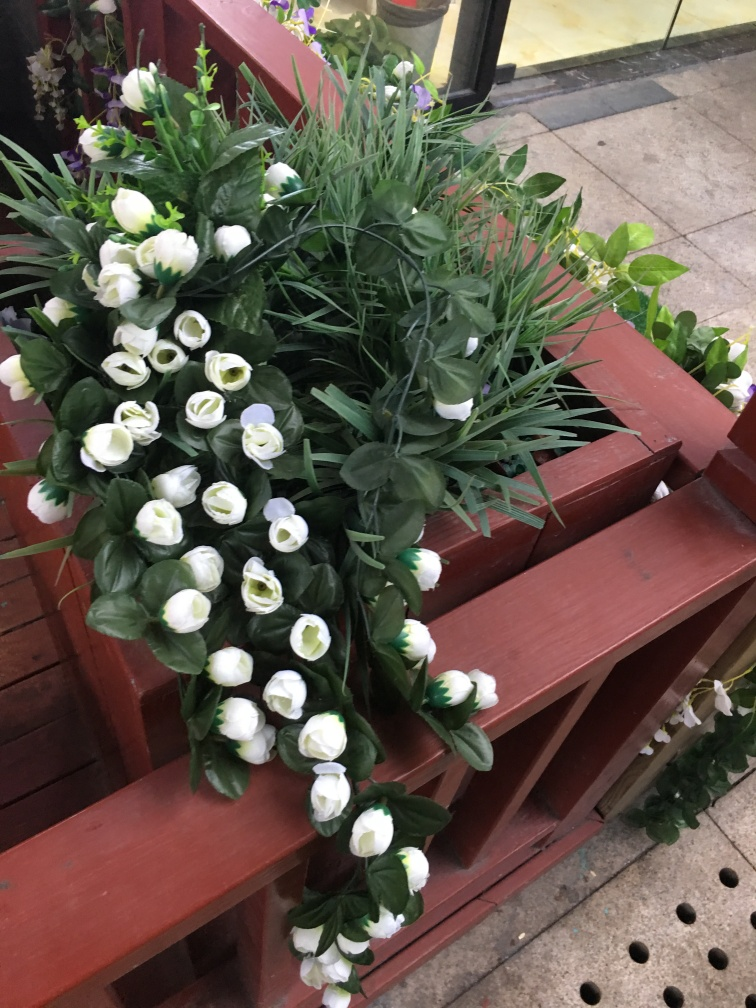Can you tell me more about the type of flowers shown in the picture? The flowers depicted in the image are artificial replicas of white tulips, characterized by their cup-shaped blooms and distinctive petal arrangement. Although they are not real, they provide an aesthetic that mimics the feel of fresh flowers and are often used for decor that requires long-lasting elements without the need for water or care.  For what occasions would these artificial flowers be appropriate as decorations? These artificial white tulips are versatile decor elements suitable for a variety of occasions. They can bring a touch of elegance to everyday settings, or be used in events such as weddings, anniversaries, or other celebratory occasions where flowers add to the atmosphere but require durability and minimal maintenance. They're also a lovely choice for crafting permanent floral displays, window shop designs, or as part of a home's interior decor scheme. 